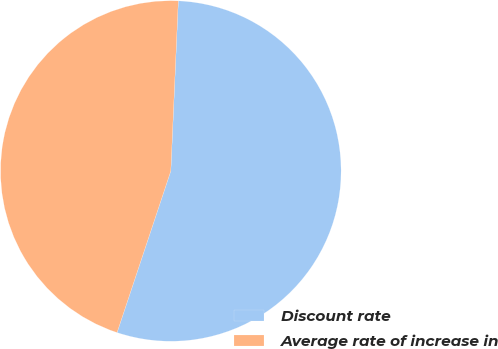Convert chart to OTSL. <chart><loc_0><loc_0><loc_500><loc_500><pie_chart><fcel>Discount rate<fcel>Average rate of increase in<nl><fcel>54.41%<fcel>45.59%<nl></chart> 